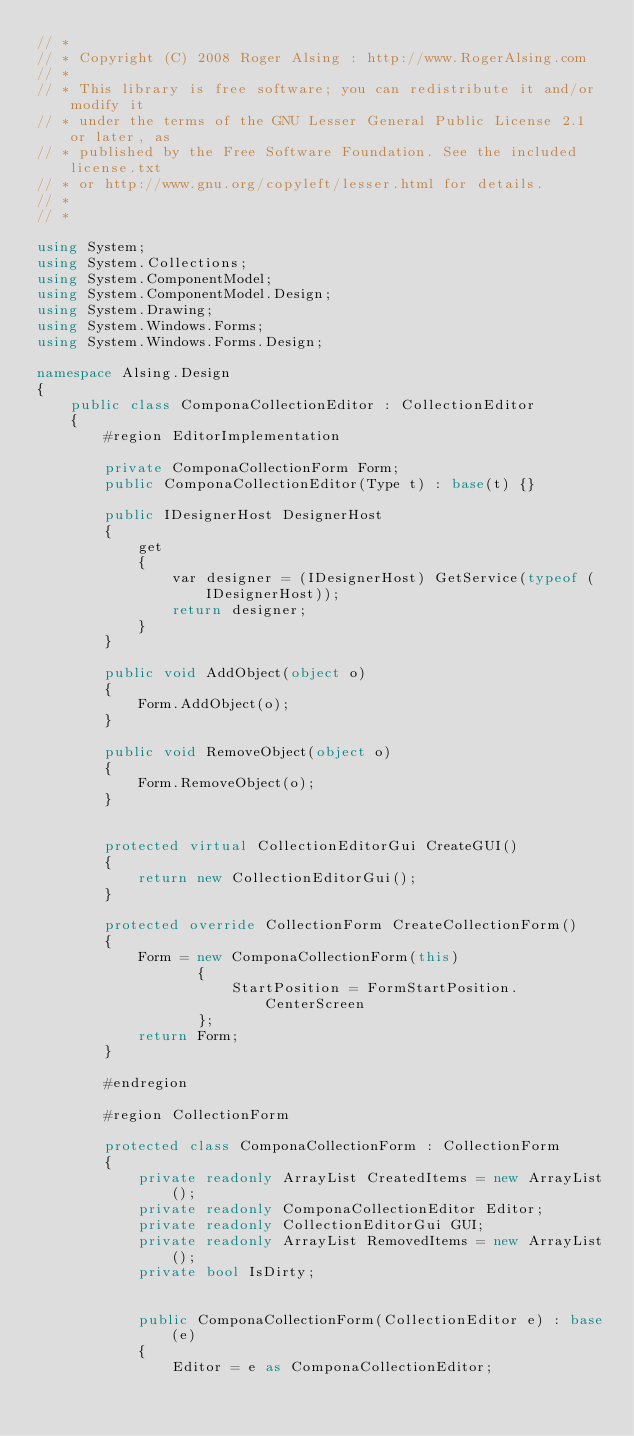Convert code to text. <code><loc_0><loc_0><loc_500><loc_500><_C#_>// *
// * Copyright (C) 2008 Roger Alsing : http://www.RogerAlsing.com
// *
// * This library is free software; you can redistribute it and/or modify it
// * under the terms of the GNU Lesser General Public License 2.1 or later, as
// * published by the Free Software Foundation. See the included license.txt
// * or http://www.gnu.org/copyleft/lesser.html for details.
// *
// *

using System;
using System.Collections;
using System.ComponentModel;
using System.ComponentModel.Design;
using System.Drawing;
using System.Windows.Forms;
using System.Windows.Forms.Design;

namespace Alsing.Design
{
    public class ComponaCollectionEditor : CollectionEditor
    {
        #region EditorImplementation

        private ComponaCollectionForm Form;
        public ComponaCollectionEditor(Type t) : base(t) {}

        public IDesignerHost DesignerHost
        {
            get
            {
                var designer = (IDesignerHost) GetService(typeof (IDesignerHost));
                return designer;
            }
        }

        public void AddObject(object o)
        {
            Form.AddObject(o);
        }

        public void RemoveObject(object o)
        {
            Form.RemoveObject(o);
        }


        protected virtual CollectionEditorGui CreateGUI()
        {
            return new CollectionEditorGui();
        }

        protected override CollectionForm CreateCollectionForm()
        {
            Form = new ComponaCollectionForm(this)
                   {
                       StartPosition = FormStartPosition.CenterScreen
                   };
            return Form;
        }

        #endregion

        #region CollectionForm

        protected class ComponaCollectionForm : CollectionForm
        {
            private readonly ArrayList CreatedItems = new ArrayList();
            private readonly ComponaCollectionEditor Editor;
            private readonly CollectionEditorGui GUI;
            private readonly ArrayList RemovedItems = new ArrayList();
            private bool IsDirty;


            public ComponaCollectionForm(CollectionEditor e) : base(e)
            {
                Editor = e as ComponaCollectionEditor;
</code> 